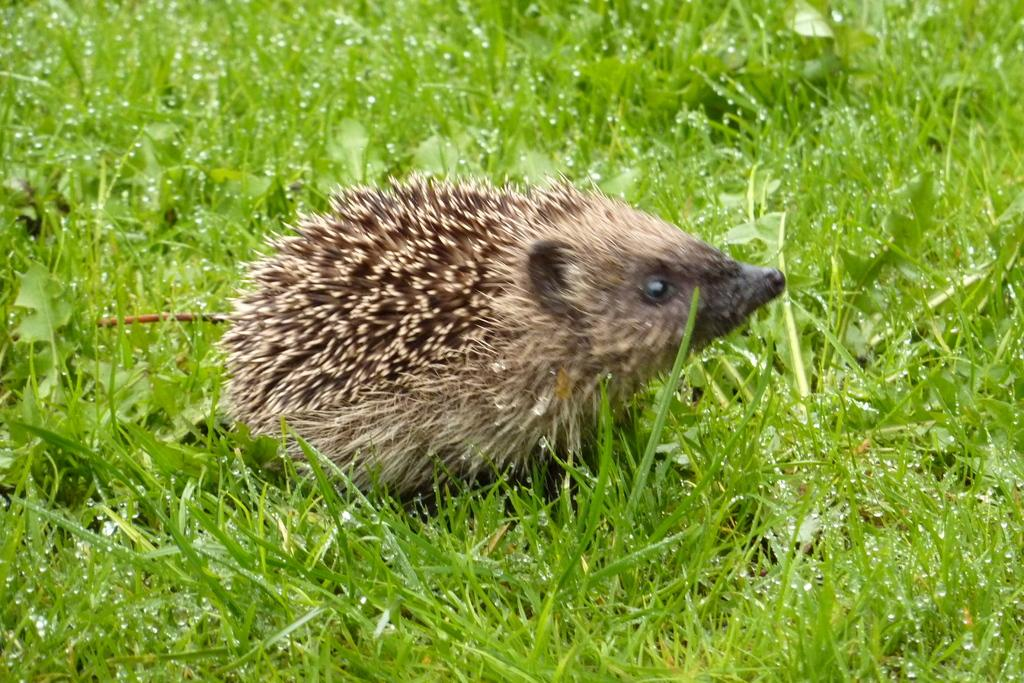What type of vegetation is present on the ground in the image? There is grass on the ground in the image. What other types of vegetation can be seen in the image? There are small plants in the image. What kind of living creature is in the image? There is an animal in the image. What color is the animal in the image? The animal is brown in color. What type of bean is being used as a fork in the image? There is no bean or fork present in the image. 